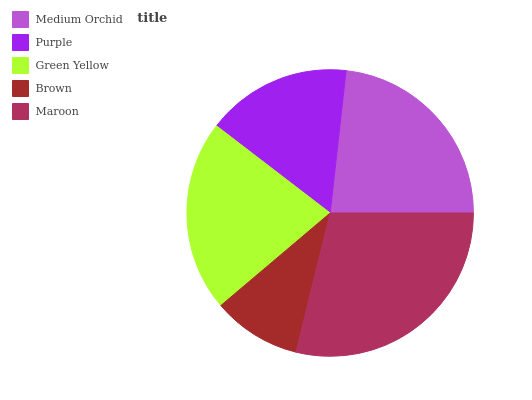Is Brown the minimum?
Answer yes or no. Yes. Is Maroon the maximum?
Answer yes or no. Yes. Is Purple the minimum?
Answer yes or no. No. Is Purple the maximum?
Answer yes or no. No. Is Medium Orchid greater than Purple?
Answer yes or no. Yes. Is Purple less than Medium Orchid?
Answer yes or no. Yes. Is Purple greater than Medium Orchid?
Answer yes or no. No. Is Medium Orchid less than Purple?
Answer yes or no. No. Is Green Yellow the high median?
Answer yes or no. Yes. Is Green Yellow the low median?
Answer yes or no. Yes. Is Maroon the high median?
Answer yes or no. No. Is Brown the low median?
Answer yes or no. No. 